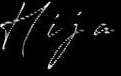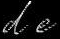Read the text from these images in sequence, separated by a semicolon. Hija; de 